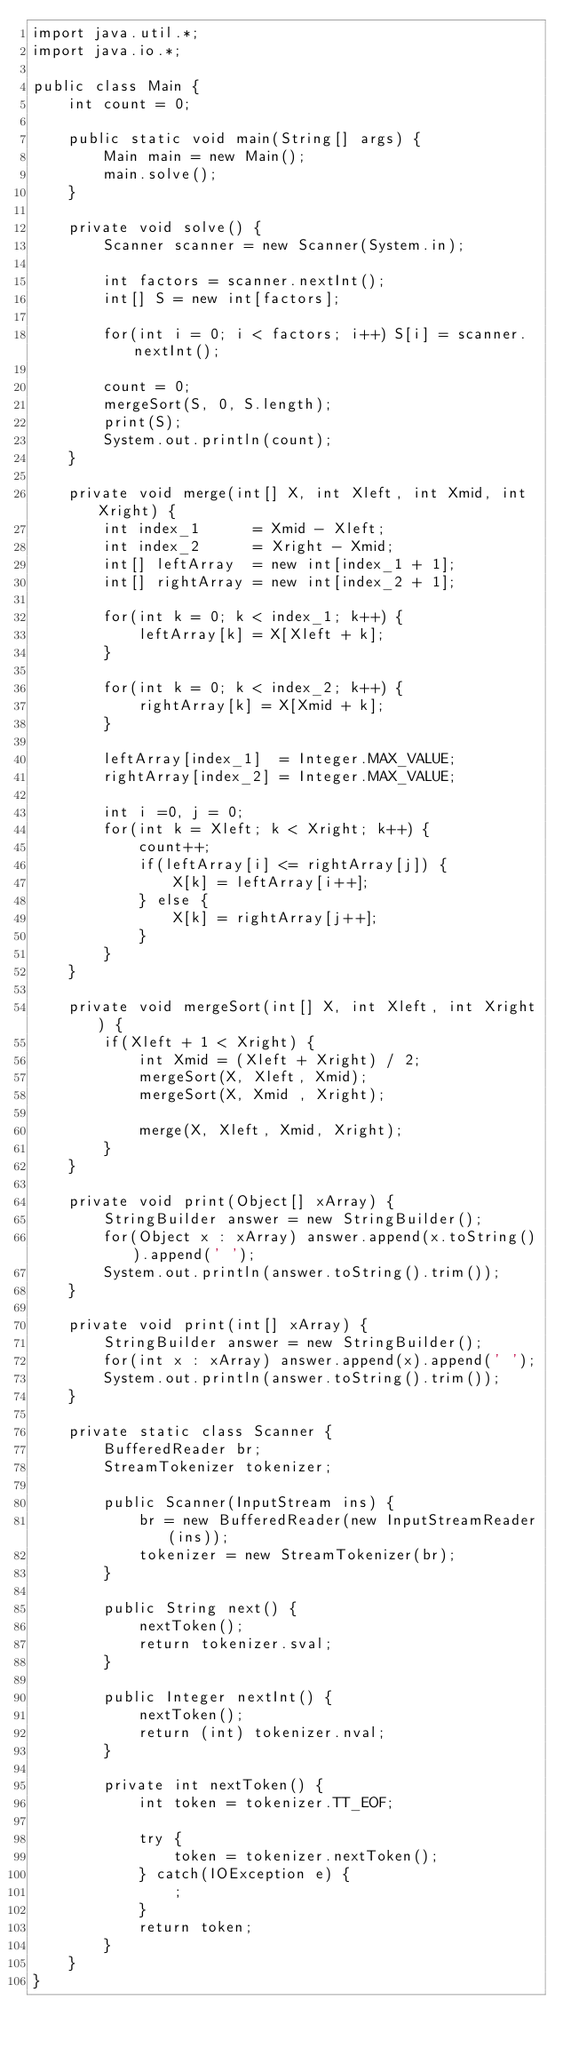Convert code to text. <code><loc_0><loc_0><loc_500><loc_500><_Java_>import java.util.*;
import java.io.*;

public class Main {
    int count = 0;
    
    public static void main(String[] args) {
        Main main = new Main();
        main.solve();
    }
    
    private void solve() {
        Scanner scanner = new Scanner(System.in);
        
        int factors = scanner.nextInt();
        int[] S = new int[factors];
        
        for(int i = 0; i < factors; i++) S[i] = scanner.nextInt();
        
        count = 0;
        mergeSort(S, 0, S.length);
        print(S);
        System.out.println(count);
    }
    
    private void merge(int[] X, int Xleft, int Xmid, int Xright) {
        int index_1      = Xmid - Xleft;
        int index_2      = Xright - Xmid;
        int[] leftArray  = new int[index_1 + 1];
        int[] rightArray = new int[index_2 + 1];
        
        for(int k = 0; k < index_1; k++) {
            leftArray[k] = X[Xleft + k];
        }
        
        for(int k = 0; k < index_2; k++) {
            rightArray[k] = X[Xmid + k];
        }
        
        leftArray[index_1]  = Integer.MAX_VALUE;
        rightArray[index_2] = Integer.MAX_VALUE;
        
        int i =0, j = 0;
        for(int k = Xleft; k < Xright; k++) {
            count++;
            if(leftArray[i] <= rightArray[j]) {
                X[k] = leftArray[i++];
            } else {
                X[k] = rightArray[j++];
            }
        }
    }
    
    private void mergeSort(int[] X, int Xleft, int Xright) {
        if(Xleft + 1 < Xright) {
            int Xmid = (Xleft + Xright) / 2;
            mergeSort(X, Xleft, Xmid);
            mergeSort(X, Xmid , Xright);
            
            merge(X, Xleft, Xmid, Xright);
        } 
    }
    
    private void print(Object[] xArray) {
        StringBuilder answer = new StringBuilder();
        for(Object x : xArray) answer.append(x.toString()).append(' ');
        System.out.println(answer.toString().trim());
    }
    
    private void print(int[] xArray) {
        StringBuilder answer = new StringBuilder();
        for(int x : xArray) answer.append(x).append(' ');
        System.out.println(answer.toString().trim());
    }
    
    private static class Scanner {
        BufferedReader br;
        StreamTokenizer tokenizer;
        
        public Scanner(InputStream ins) {
            br = new BufferedReader(new InputStreamReader(ins));
            tokenizer = new StreamTokenizer(br);
        }
        
        public String next() {
            nextToken();
            return tokenizer.sval;
        }
        
        public Integer nextInt() {
            nextToken();
            return (int) tokenizer.nval;
        }
        
        private int nextToken() {
            int token = tokenizer.TT_EOF;
            
            try {
                token = tokenizer.nextToken();
            } catch(IOException e) {
                ;
            }
            return token;
        }
    }
}
</code> 